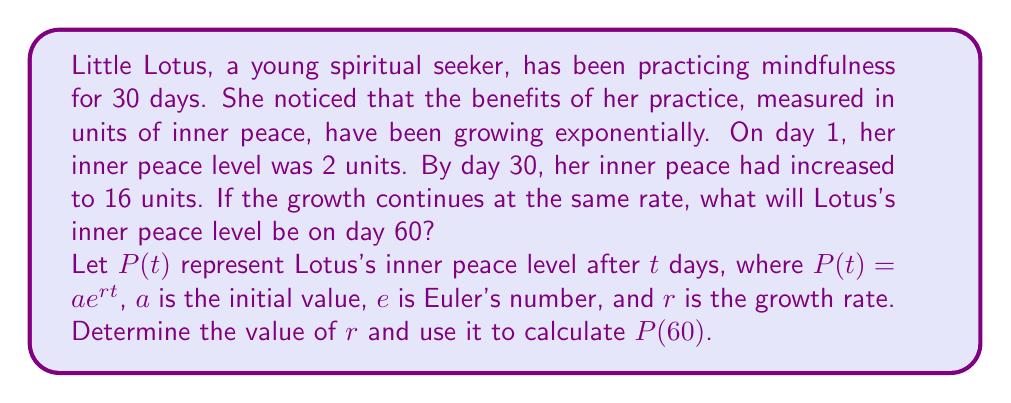Show me your answer to this math problem. Let's approach this step-by-step:

1) We know that $P(t) = ae^{rt}$, where $a = 2$ (initial value on day 1).

2) We can set up two equations based on the given information:
   $P(1) = 2 = 2e^{r(1)}$
   $P(30) = 16 = 2e^{r(30)}$

3) From the second equation:
   $16 = 2e^{30r}$
   $8 = e^{30r}$

4) Taking the natural logarithm of both sides:
   $\ln(8) = 30r$
   $r = \frac{\ln(8)}{30}$

5) Calculate $r$:
   $r = \frac{\ln(8)}{30} \approx 0.0693$

6) Now that we have $r$, we can calculate $P(60)$:
   $P(60) = 2e^{0.0693(60)}$

7) Simplify:
   $P(60) = 2e^{4.158} \approx 127.79$

Therefore, on day 60, Lotus's inner peace level will be approximately 127.79 units.
Answer: $P(60) \approx 127.79$ units of inner peace 